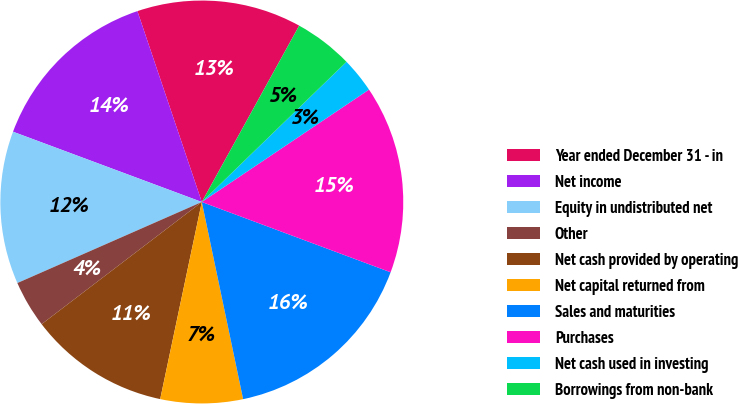<chart> <loc_0><loc_0><loc_500><loc_500><pie_chart><fcel>Year ended December 31 - in<fcel>Net income<fcel>Equity in undistributed net<fcel>Other<fcel>Net cash provided by operating<fcel>Net capital returned from<fcel>Sales and maturities<fcel>Purchases<fcel>Net cash used in investing<fcel>Borrowings from non-bank<nl><fcel>13.21%<fcel>14.15%<fcel>12.26%<fcel>3.78%<fcel>11.32%<fcel>6.6%<fcel>16.04%<fcel>15.09%<fcel>2.83%<fcel>4.72%<nl></chart> 